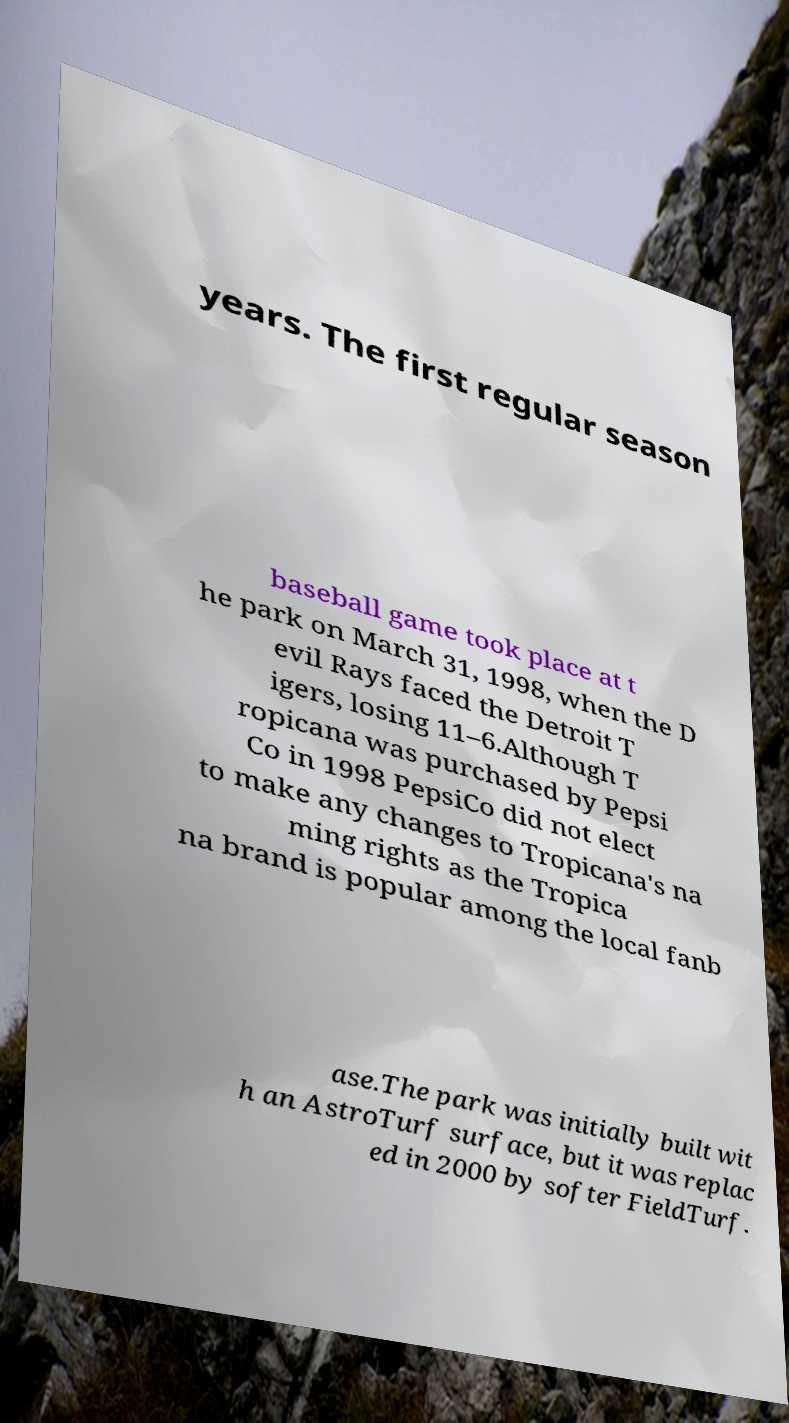Please identify and transcribe the text found in this image. years. The first regular season baseball game took place at t he park on March 31, 1998, when the D evil Rays faced the Detroit T igers, losing 11–6.Although T ropicana was purchased by Pepsi Co in 1998 PepsiCo did not elect to make any changes to Tropicana's na ming rights as the Tropica na brand is popular among the local fanb ase.The park was initially built wit h an AstroTurf surface, but it was replac ed in 2000 by softer FieldTurf. 